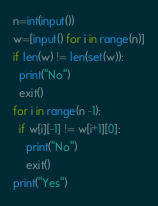Convert code to text. <code><loc_0><loc_0><loc_500><loc_500><_Python_>n=int(input())
w=[input() for i in range(n)]
if len(w) != len(set(w)):
  print("No")
  exit()
for i in range(n -1):
  if w[i][-1] != w[i+1][0]:
    print("No")
    exit()
print("Yes")</code> 